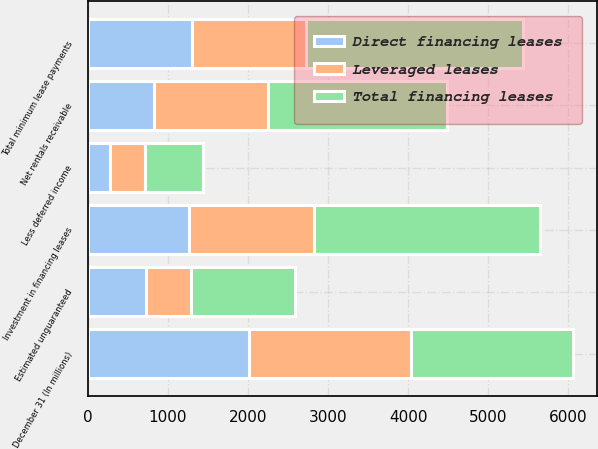Convert chart. <chart><loc_0><loc_0><loc_500><loc_500><stacked_bar_chart><ecel><fcel>December 31 (In millions)<fcel>Total minimum lease payments<fcel>Net rentals receivable<fcel>Estimated unguaranteed<fcel>Less deferred income<fcel>Investment in financing leases<nl><fcel>Total financing leases<fcel>2018<fcel>2719<fcel>2245<fcel>1295<fcel>718<fcel>2822<nl><fcel>Leveraged leases<fcel>2018<fcel>1421<fcel>1421<fcel>571<fcel>437<fcel>1556<nl><fcel>Direct financing leases<fcel>2018<fcel>1298<fcel>824<fcel>724<fcel>282<fcel>1266<nl></chart> 